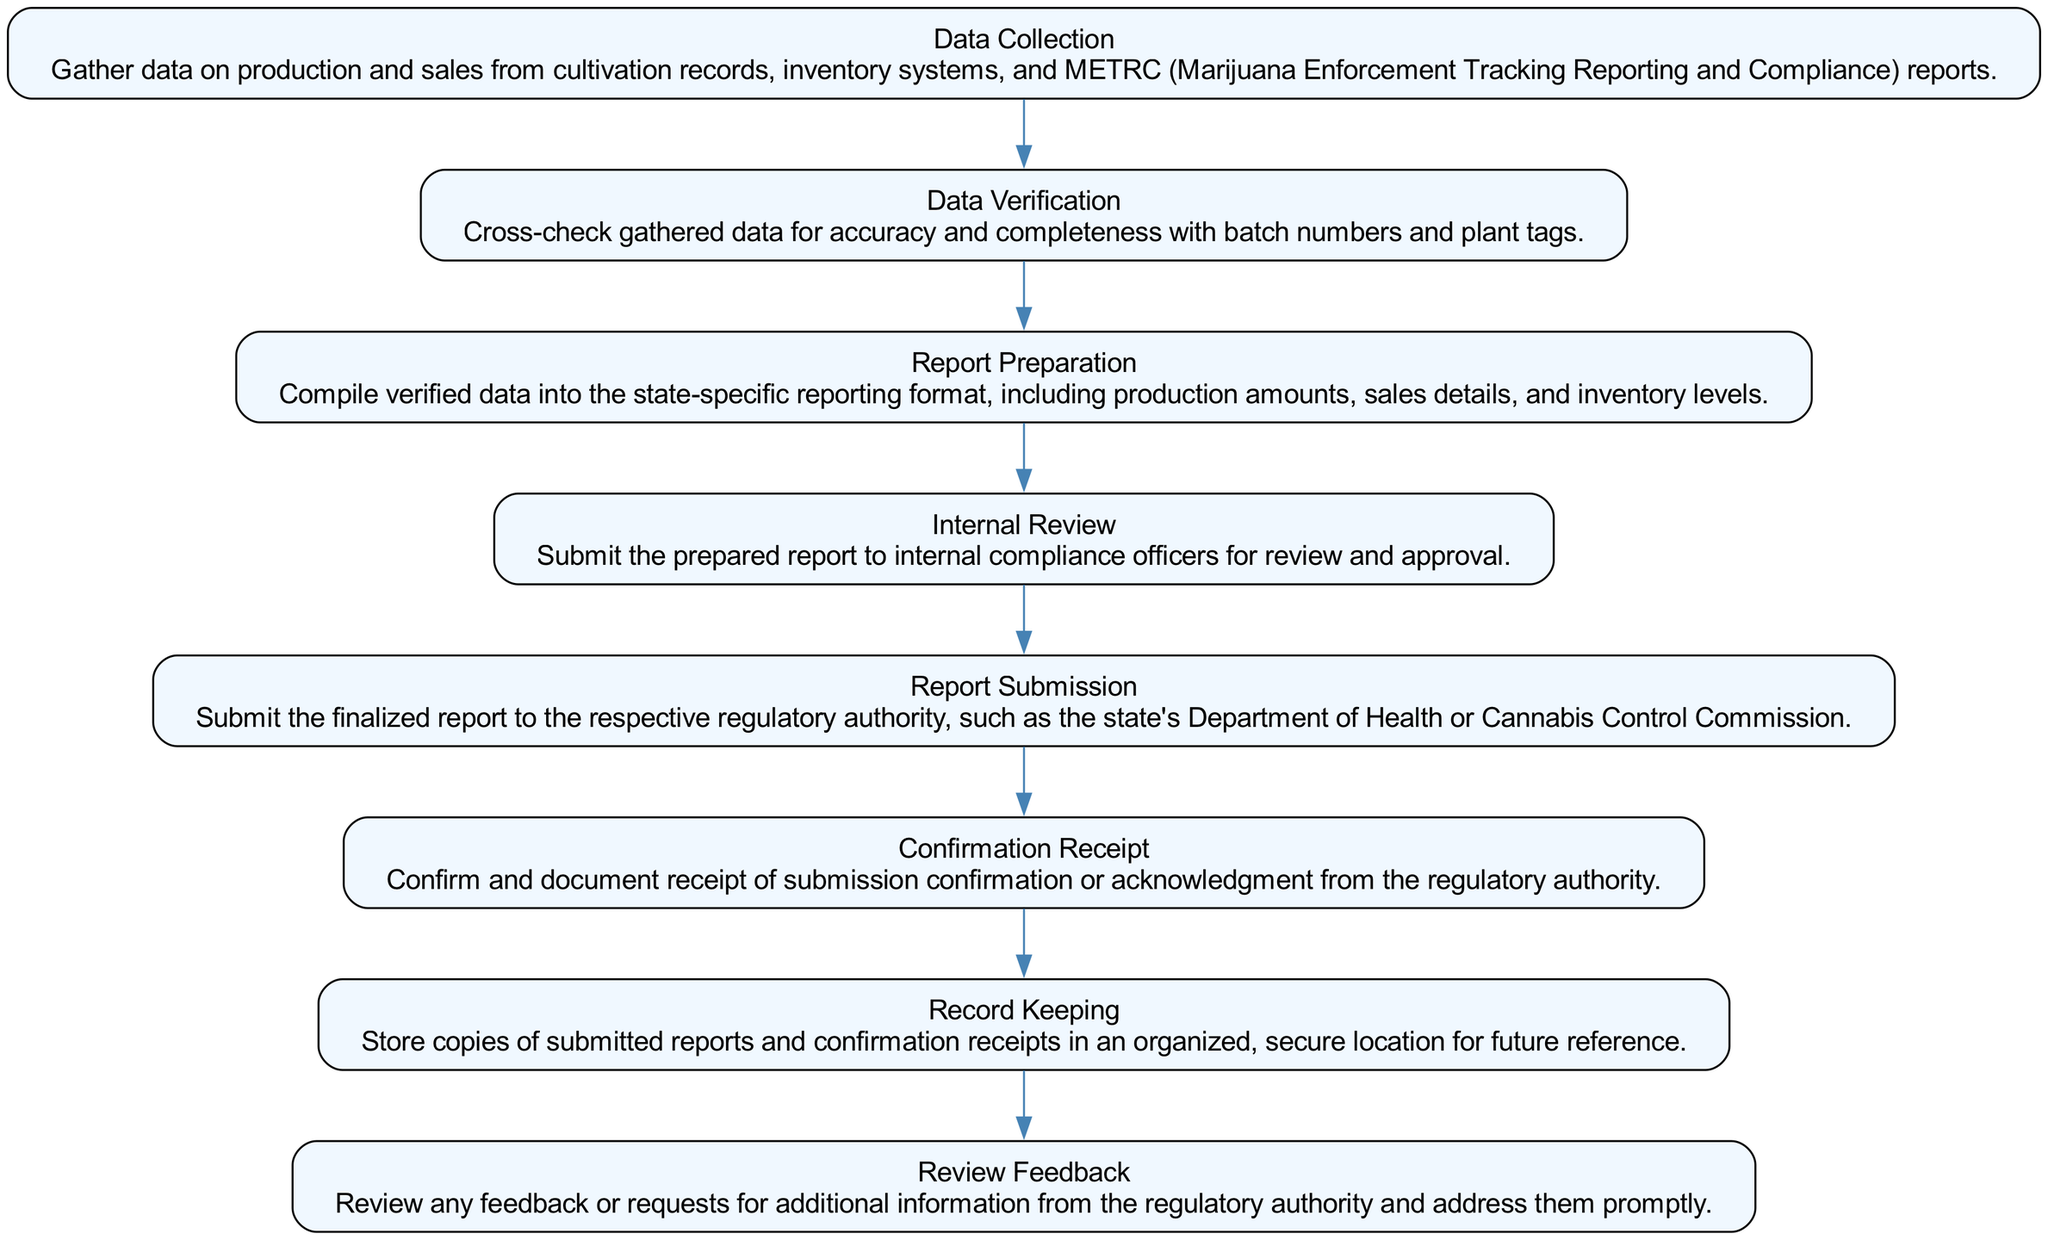What is the first step in the workflow? The diagram indicates that the first step in the workflow is "Data Collection," which involves gathering data from various sources.
Answer: Data Collection How many nodes are in the diagram? By counting the individual steps represented in the diagram, we can see there are eight distinct nodes outlining the workflow.
Answer: Eight What is the last step in the process? The last step shown in the diagram is "Record Keeping," which emphasizes the importance of storing documentation securely.
Answer: Record Keeping Which step follows "Internal Review"? According to the sequence in the diagram, "Report Submission" directly follows "Internal Review," indicating the next action to take.
Answer: Report Submission What happens if feedback is received from the regulatory authority? The diagram specifies that if feedback is received, you must go through "Review Feedback," which includes addressing any requests or feedback promptly.
Answer: Review Feedback How are the steps in the diagram connected? The steps are connected in a linear fashion, meaning each step leads to the next, forming a continuous workflow towards compliance.
Answer: Linear fashion Which node involves confirming submission? The node that involves confirming submission is "Confirmation Receipt," which indicates the need to document acknowledgment from the regulatory authority.
Answer: Confirmation Receipt What is necessary before "Report Submission"? Before proceeding to "Report Submission," it is necessary to complete "Internal Review," which checks the report for compliance.
Answer: Internal Review What is the purpose of "Data Verification"? The purpose of "Data Verification" is to ensure that the collected data is accurate and complete by cross-checking it with established identifiers.
Answer: Ensure accuracy 